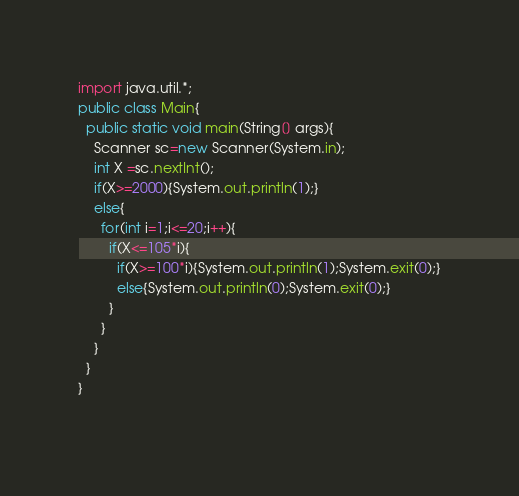<code> <loc_0><loc_0><loc_500><loc_500><_Java_>import java.util.*;
public class Main{
  public static void main(String[] args){
    Scanner sc=new Scanner(System.in);
    int X =sc.nextInt();
    if(X>=2000){System.out.println(1);}
    else{
      for(int i=1;i<=20;i++){
        if(X<=105*i){
          if(X>=100*i){System.out.println(1);System.exit(0);}
          else{System.out.println(0);System.exit(0);}
        }
      }
    }
  }
}
      </code> 